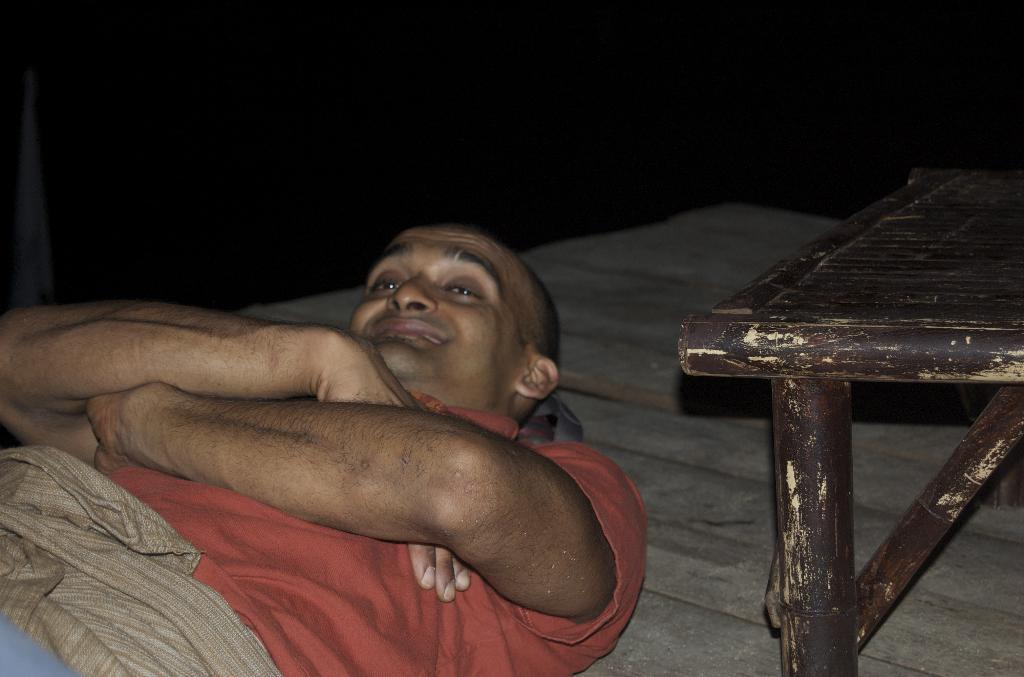What is the man in the image doing? The man is lying on the floor in the image. What can be seen on the right side of the image? There is a wooden table on the right side of the image. What type of hearing aid is the man wearing in the image? There is no hearing aid visible in the image, as the man is lying on the floor and no such device is mentioned in the facts. 